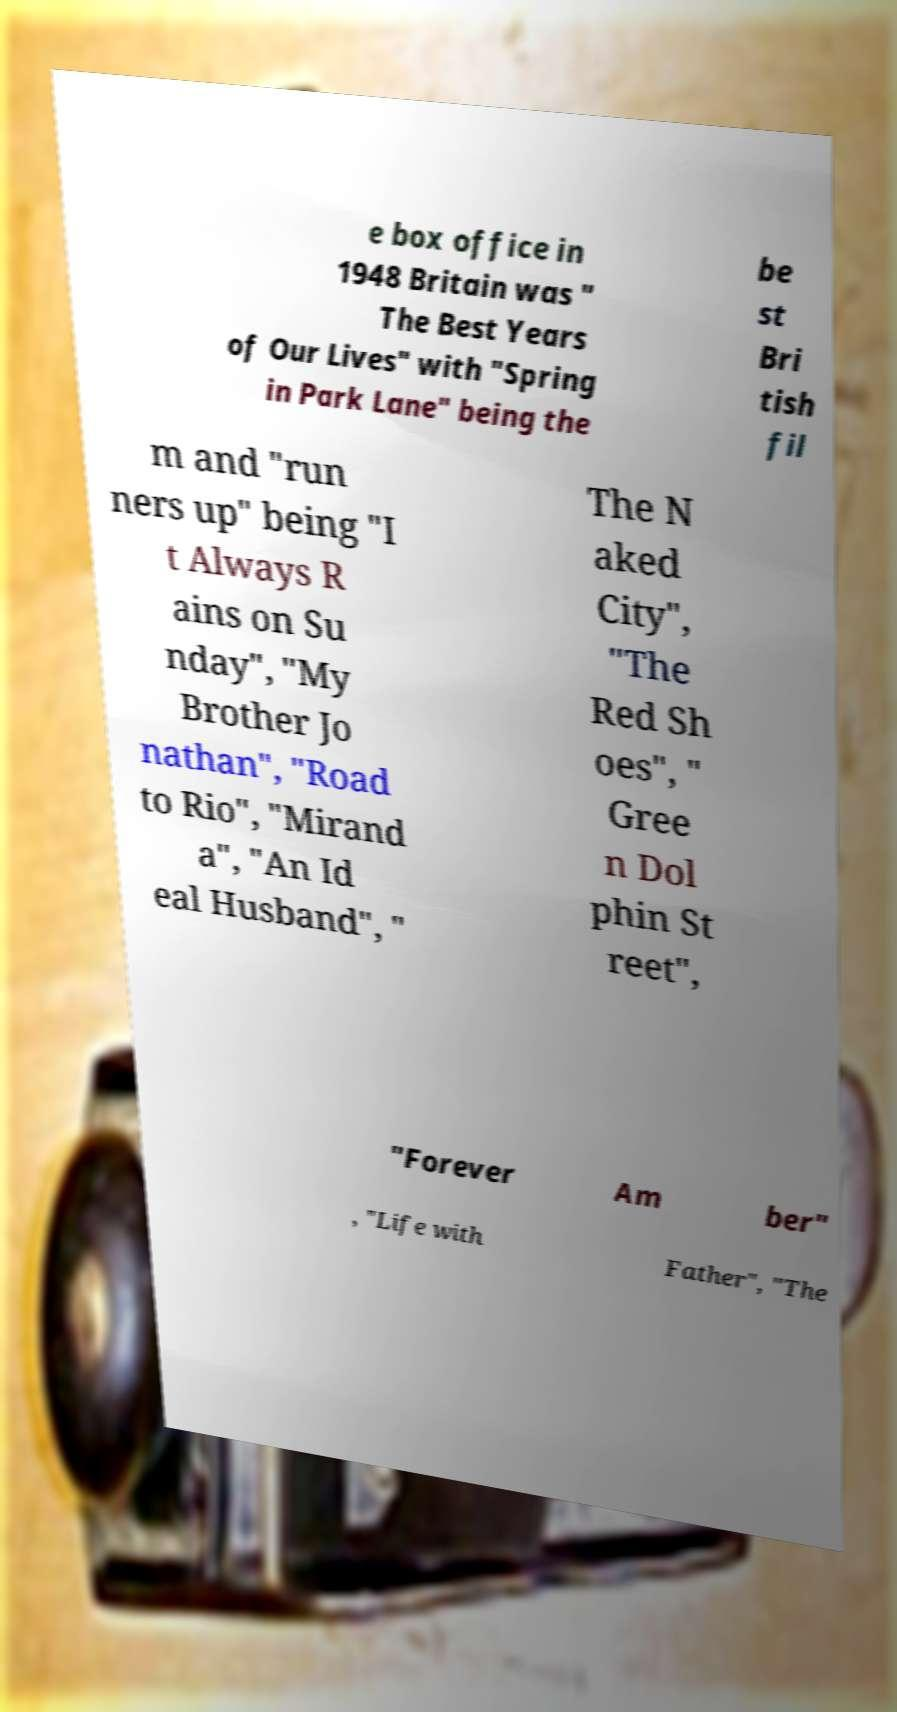For documentation purposes, I need the text within this image transcribed. Could you provide that? e box office in 1948 Britain was " The Best Years of Our Lives" with "Spring in Park Lane" being the be st Bri tish fil m and "run ners up" being "I t Always R ains on Su nday", "My Brother Jo nathan", "Road to Rio", "Mirand a", "An Id eal Husband", " The N aked City", "The Red Sh oes", " Gree n Dol phin St reet", "Forever Am ber" , "Life with Father", "The 